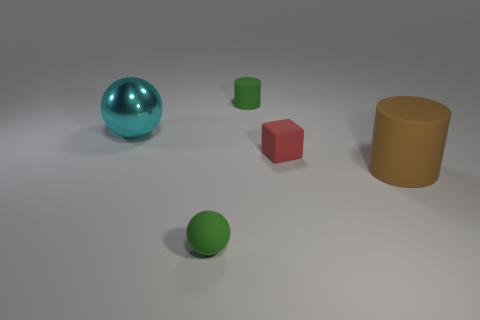Add 2 rubber things. How many objects exist? 7 Subtract all balls. How many objects are left? 3 Add 2 large blue metallic cylinders. How many large blue metallic cylinders exist? 2 Subtract 0 yellow cubes. How many objects are left? 5 Subtract all yellow cylinders. Subtract all green cubes. How many cylinders are left? 2 Subtract all tiny yellow metal cylinders. Subtract all brown cylinders. How many objects are left? 4 Add 2 green rubber objects. How many green rubber objects are left? 4 